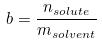Convert formula to latex. <formula><loc_0><loc_0><loc_500><loc_500>b = \frac { n _ { s o l u t e } } { m _ { s o l v e n t } }</formula> 